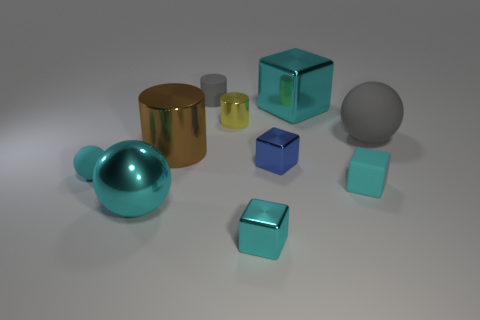Do the big sphere that is left of the gray rubber cylinder and the matte block have the same color?
Offer a very short reply. Yes. Is the number of cyan rubber balls behind the brown shiny cylinder greater than the number of metal things in front of the blue object?
Provide a succinct answer. No. Is there anything else of the same color as the large cylinder?
Ensure brevity in your answer.  No. What number of things are large yellow rubber blocks or small gray rubber cylinders?
Provide a succinct answer. 1. There is a shiny cylinder behind the brown thing; is it the same size as the large gray object?
Your answer should be very brief. No. How many other objects are the same size as the blue metallic block?
Your answer should be very brief. 5. Is there a tiny purple metallic ball?
Offer a terse response. No. There is a cyan sphere that is right of the rubber sphere that is in front of the big brown metal thing; what is its size?
Ensure brevity in your answer.  Large. Does the sphere behind the tiny blue metallic block have the same color as the tiny rubber object that is behind the tiny blue metallic object?
Make the answer very short. Yes. The small matte object that is both in front of the small gray rubber thing and right of the large cyan metal ball is what color?
Provide a succinct answer. Cyan. 